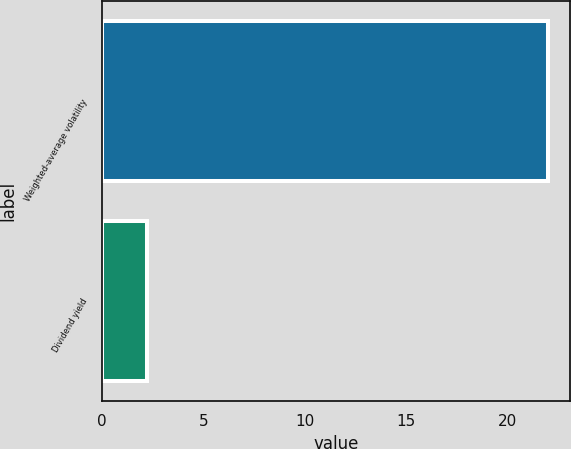Convert chart. <chart><loc_0><loc_0><loc_500><loc_500><bar_chart><fcel>Weighted-average volatility<fcel>Dividend yield<nl><fcel>22<fcel>2.22<nl></chart> 